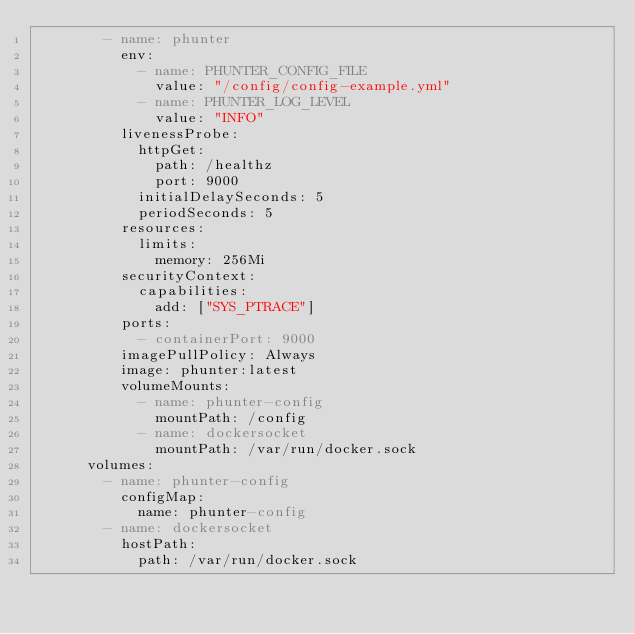<code> <loc_0><loc_0><loc_500><loc_500><_YAML_>        - name: phunter
          env:
            - name: PHUNTER_CONFIG_FILE
              value: "/config/config-example.yml"
            - name: PHUNTER_LOG_LEVEL
              value: "INFO"
          livenessProbe:
            httpGet:
              path: /healthz
              port: 9000
            initialDelaySeconds: 5
            periodSeconds: 5
          resources:
            limits:
              memory: 256Mi
          securityContext:
            capabilities:
              add: ["SYS_PTRACE"]
          ports:
            - containerPort: 9000
          imagePullPolicy: Always
          image: phunter:latest
          volumeMounts:
            - name: phunter-config
              mountPath: /config
            - name: dockersocket
              mountPath: /var/run/docker.sock
      volumes:
        - name: phunter-config
          configMap:
            name: phunter-config
        - name: dockersocket
          hostPath:
            path: /var/run/docker.sock</code> 